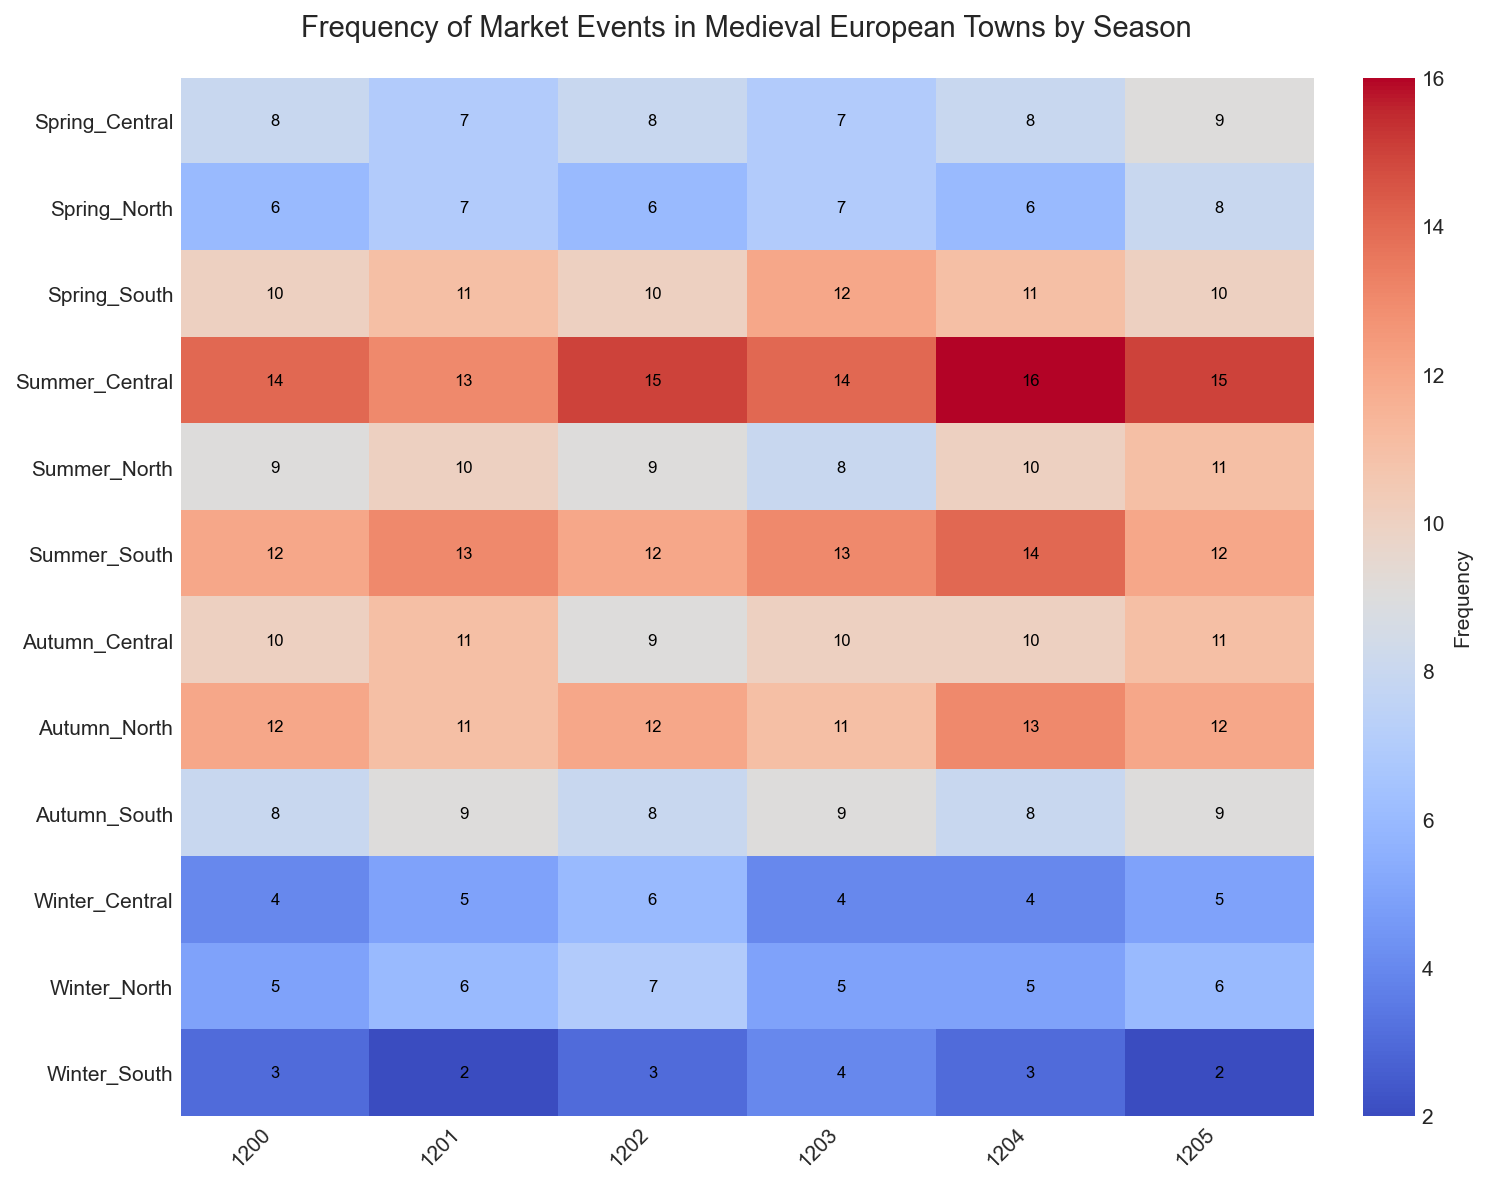What is the frequency of market events in North towns during Spring in 1203? Find the cell for the year 1203 in the row labeled 'North' and look at the column 'Spring'. The value is 7.
Answer: 7 Which season had the highest frequency of market events in Central towns in 1204? In the row for the year 1204, find the highest value among the 'Spring', 'Summer', 'Autumn', and 'Winter' columns under 'Central'. The highest value is 16, which corresponds to 'Summer'.
Answer: Summer How does the average frequency of market events in Summer compare between North and South towns over all years? Calculate the average frequency of market events in Summer for both North and South towns. For North: (9+10+9+8+10+11)/6 = 9.5. For South: (12+13+12+13+14+12)/6 = 12.67. Compare these two averages.
Answer: South During which year did the South towns experience their highest frequency of market events in Winter? Look at the 'Winter' column for South towns across all the years. The highest value is 4, which occurs in 1203.
Answer: 1203 What is the total frequency of market events in Central towns during Autumn over all years? Sum the values in the 'Autumn' column for Central towns across all the years: 10+11+9+10+10+11 = 61.
Answer: 61 Which region had the lowest frequency of market events in Winter in 1200? Compare the 'Winter' column values for the year 1200 across North (5), Central (4), and South (3). The lowest value is 3 in South.
Answer: South What is the difference in frequency of market events between Summer and Winter in North towns in 1202? Find the values for Summer (9) and Winter (7) in the year 1202 for North towns and subtract: 9 - 7 = 2.
Answer: 2 What trend can be observed in the frequency of market events in Central towns during Summer from 1200 to 1205? Notice the values for Summer in Central towns: 14, 13, 15, 14, 16, 15. The trend shows an overall increase with minor fluctuations.
Answer: Increasing trend 